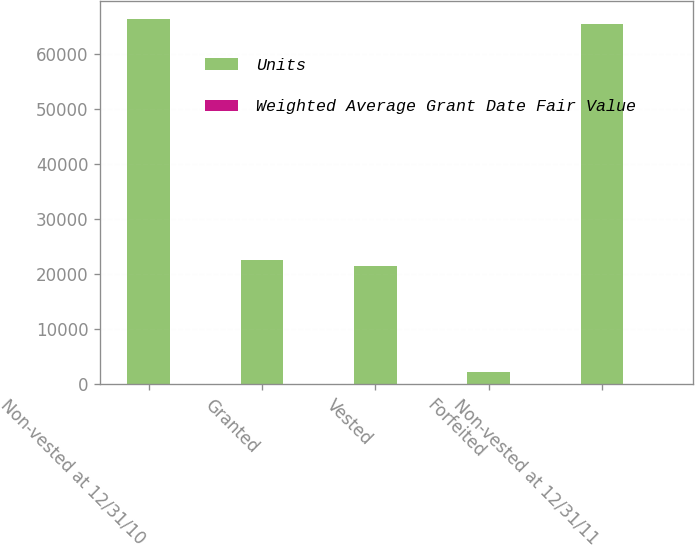Convert chart to OTSL. <chart><loc_0><loc_0><loc_500><loc_500><stacked_bar_chart><ecel><fcel>Non-vested at 12/31/10<fcel>Granted<fcel>Vested<fcel>Forfeited<fcel>Non-vested at 12/31/11<nl><fcel>Units<fcel>66359<fcel>22620<fcel>21403<fcel>2156<fcel>65420<nl><fcel>Weighted Average Grant Date Fair Value<fcel>41.33<fcel>50.72<fcel>39.7<fcel>43.28<fcel>45.05<nl></chart> 